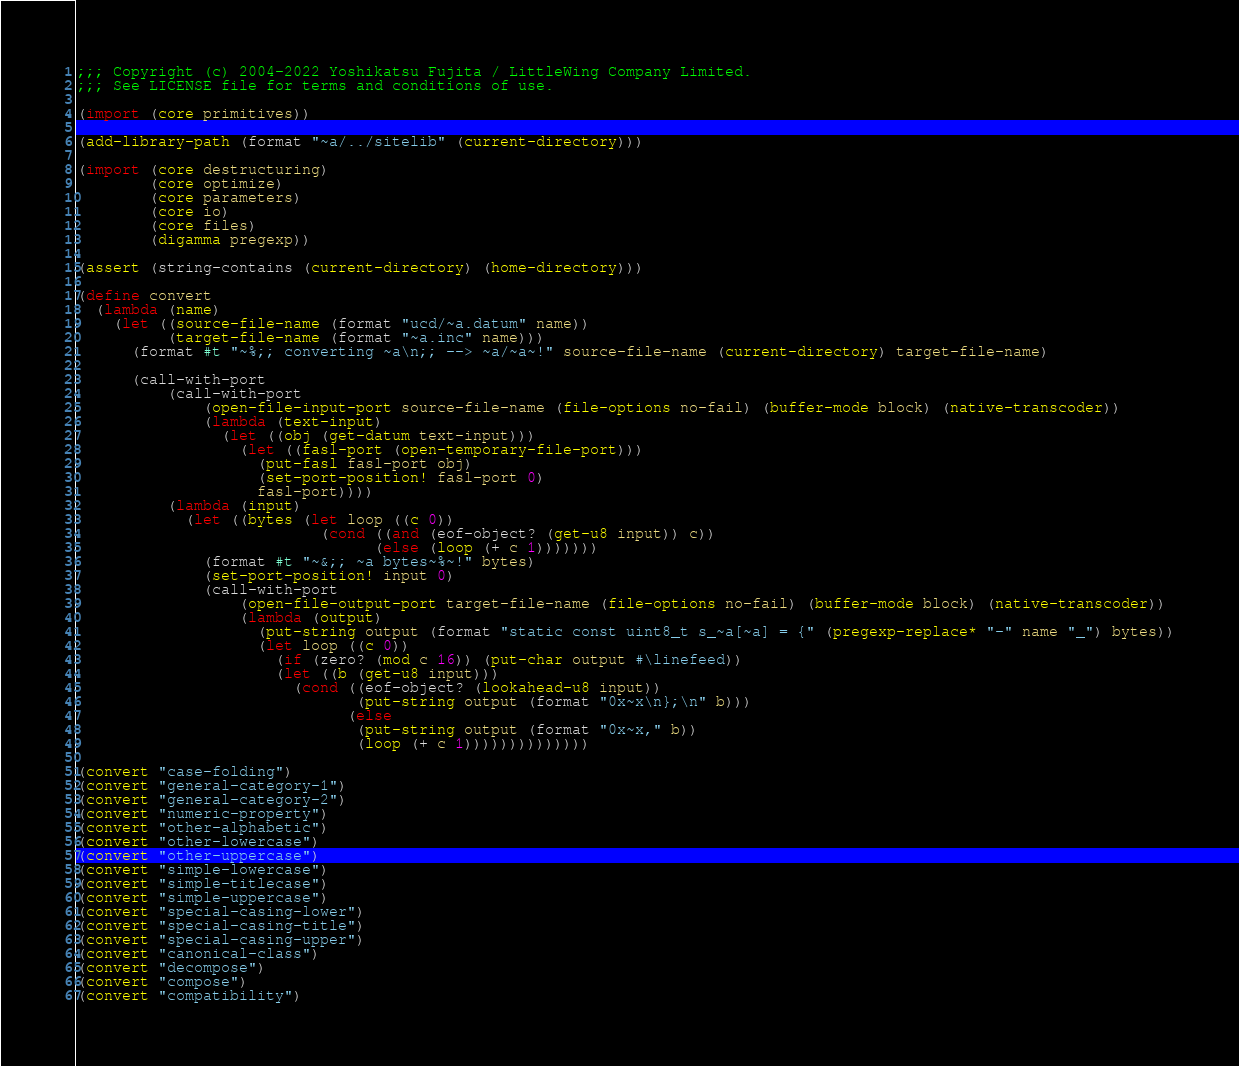Convert code to text. <code><loc_0><loc_0><loc_500><loc_500><_Scheme_>;;; Copyright (c) 2004-2022 Yoshikatsu Fujita / LittleWing Company Limited.
;;; See LICENSE file for terms and conditions of use.

(import (core primitives))

(add-library-path (format "~a/../sitelib" (current-directory)))

(import (core destructuring)
        (core optimize)
        (core parameters)
        (core io)
        (core files)
        (digamma pregexp))

(assert (string-contains (current-directory) (home-directory)))

(define convert
  (lambda (name)
    (let ((source-file-name (format "ucd/~a.datum" name))
          (target-file-name (format "~a.inc" name)))
      (format #t "~%;; converting ~a\n;; --> ~a/~a~!" source-file-name (current-directory) target-file-name)

      (call-with-port
          (call-with-port
              (open-file-input-port source-file-name (file-options no-fail) (buffer-mode block) (native-transcoder))
              (lambda (text-input)
                (let ((obj (get-datum text-input)))
                  (let ((fasl-port (open-temporary-file-port)))
                    (put-fasl fasl-port obj)
                    (set-port-position! fasl-port 0)
                    fasl-port))))
          (lambda (input)
            (let ((bytes (let loop ((c 0))
                           (cond ((and (eof-object? (get-u8 input)) c))
                                 (else (loop (+ c 1)))))))
              (format #t "~&;; ~a bytes~%~!" bytes)
              (set-port-position! input 0)
              (call-with-port
                  (open-file-output-port target-file-name (file-options no-fail) (buffer-mode block) (native-transcoder))
                  (lambda (output)
                    (put-string output (format "static const uint8_t s_~a[~a] = {" (pregexp-replace* "-" name "_") bytes))
                    (let loop ((c 0))
                      (if (zero? (mod c 16)) (put-char output #\linefeed))
                      (let ((b (get-u8 input)))
                        (cond ((eof-object? (lookahead-u8 input))
                               (put-string output (format "0x~x\n};\n" b)))
                              (else
                               (put-string output (format "0x~x," b))
                               (loop (+ c 1))))))))))))))

(convert "case-folding")
(convert "general-category-1")
(convert "general-category-2")
(convert "numeric-property")
(convert "other-alphabetic")
(convert "other-lowercase")
(convert "other-uppercase")
(convert "simple-lowercase")
(convert "simple-titlecase")
(convert "simple-uppercase")
(convert "special-casing-lower")
(convert "special-casing-title")
(convert "special-casing-upper")
(convert "canonical-class")
(convert "decompose")
(convert "compose")
(convert "compatibility")
</code> 